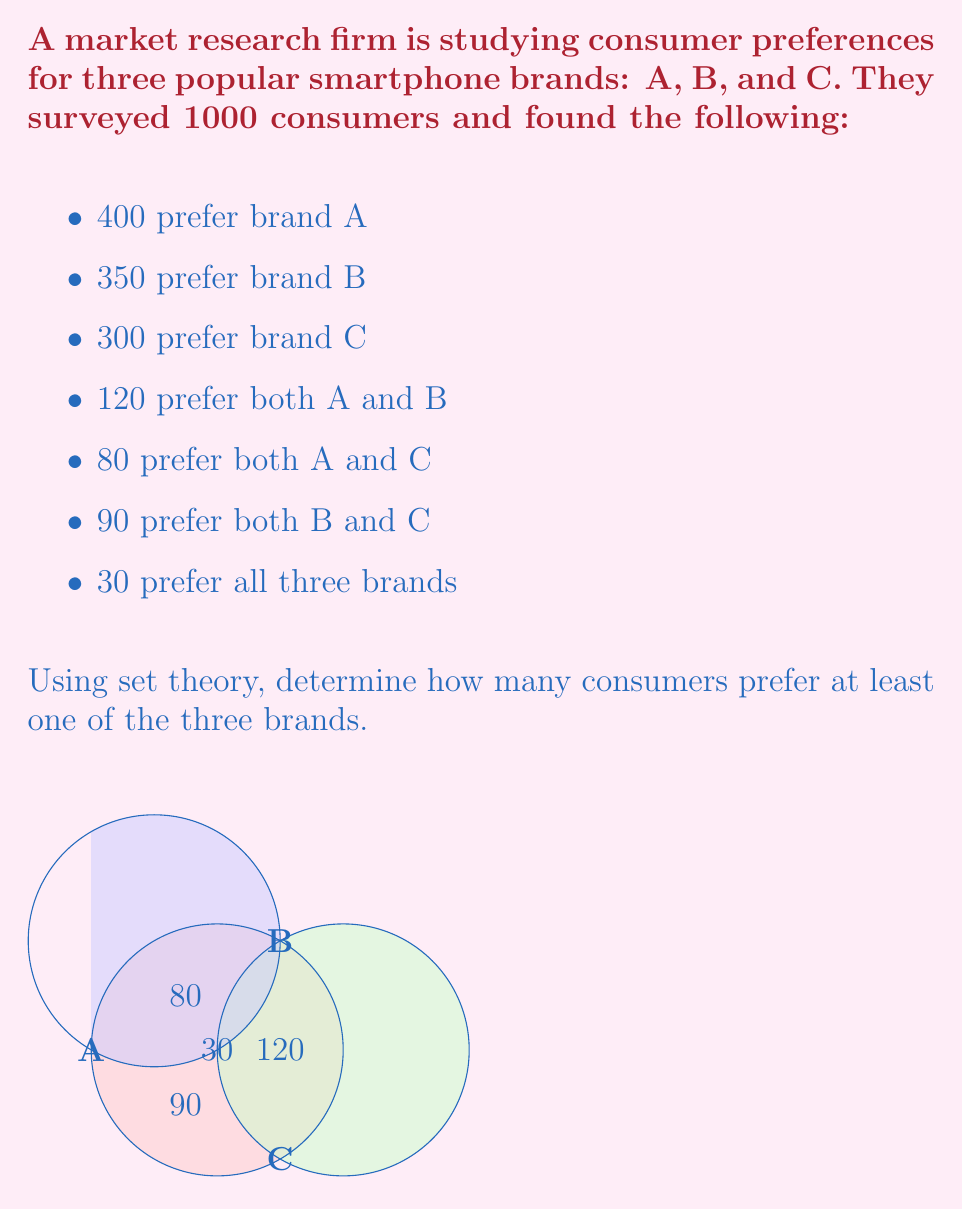Help me with this question. Let's approach this step-by-step using set theory:

1) Let's define our sets:
   A: consumers who prefer brand A
   B: consumers who prefer brand B
   C: consumers who prefer brand C

2) We need to find $|A \cup B \cup C|$, which represents the number of consumers who prefer at least one of the three brands.

3) We can use the Inclusion-Exclusion Principle:

   $$|A \cup B \cup C| = |A| + |B| + |C| - |A \cap B| - |A \cap C| - |B \cap C| + |A \cap B \cap C|$$

4) We know:
   $|A| = 400$, $|B| = 350$, $|C| = 300$
   $|A \cap B| = 120$, $|A \cap C| = 80$, $|B \cap C| = 90$
   $|A \cap B \cap C| = 30$

5) Let's substitute these values:

   $$|A \cup B \cup C| = 400 + 350 + 300 - 120 - 80 - 90 + 30$$

6) Now, let's calculate:

   $$|A \cup B \cup C| = 1050 - 290 + 30 = 790$$

Therefore, 790 consumers prefer at least one of the three brands.
Answer: 790 consumers 